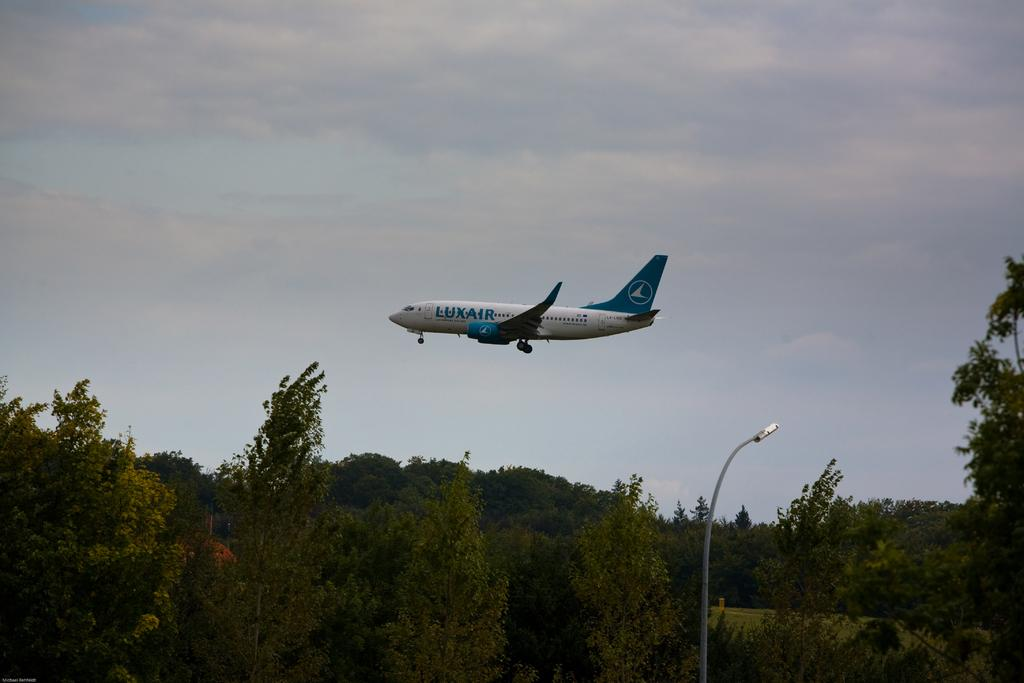<image>
Summarize the visual content of the image. A blue and white Luxair plane is flying over the early evening sky. 